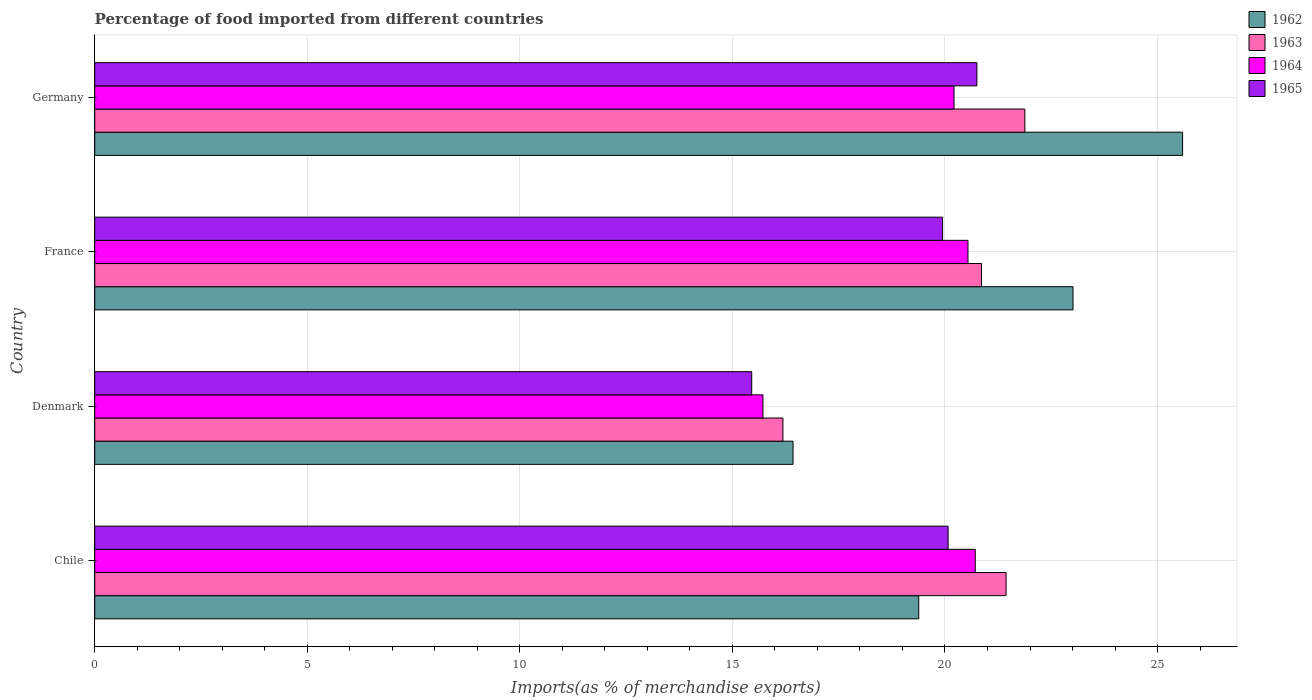Are the number of bars per tick equal to the number of legend labels?
Keep it short and to the point. Yes. Are the number of bars on each tick of the Y-axis equal?
Keep it short and to the point. Yes. How many bars are there on the 2nd tick from the bottom?
Your answer should be compact. 4. In how many cases, is the number of bars for a given country not equal to the number of legend labels?
Ensure brevity in your answer.  0. What is the percentage of imports to different countries in 1962 in France?
Ensure brevity in your answer.  23.01. Across all countries, what is the maximum percentage of imports to different countries in 1964?
Provide a succinct answer. 20.71. Across all countries, what is the minimum percentage of imports to different countries in 1965?
Your response must be concise. 15.45. In which country was the percentage of imports to different countries in 1965 maximum?
Provide a short and direct response. Germany. In which country was the percentage of imports to different countries in 1962 minimum?
Give a very brief answer. Denmark. What is the total percentage of imports to different countries in 1965 in the graph?
Keep it short and to the point. 76.22. What is the difference between the percentage of imports to different countries in 1963 in Chile and that in Denmark?
Offer a terse response. 5.25. What is the difference between the percentage of imports to different countries in 1965 in Chile and the percentage of imports to different countries in 1963 in Denmark?
Provide a succinct answer. 3.89. What is the average percentage of imports to different countries in 1962 per country?
Make the answer very short. 21.1. What is the difference between the percentage of imports to different countries in 1965 and percentage of imports to different countries in 1964 in Germany?
Your response must be concise. 0.54. In how many countries, is the percentage of imports to different countries in 1964 greater than 5 %?
Provide a succinct answer. 4. What is the ratio of the percentage of imports to different countries in 1962 in Chile to that in Denmark?
Provide a succinct answer. 1.18. Is the percentage of imports to different countries in 1964 in Chile less than that in Germany?
Keep it short and to the point. No. Is the difference between the percentage of imports to different countries in 1965 in Denmark and Germany greater than the difference between the percentage of imports to different countries in 1964 in Denmark and Germany?
Your answer should be very brief. No. What is the difference between the highest and the second highest percentage of imports to different countries in 1962?
Your answer should be very brief. 2.58. What is the difference between the highest and the lowest percentage of imports to different countries in 1962?
Keep it short and to the point. 9.16. In how many countries, is the percentage of imports to different countries in 1965 greater than the average percentage of imports to different countries in 1965 taken over all countries?
Your answer should be compact. 3. Is the sum of the percentage of imports to different countries in 1964 in Chile and France greater than the maximum percentage of imports to different countries in 1963 across all countries?
Keep it short and to the point. Yes. Is it the case that in every country, the sum of the percentage of imports to different countries in 1964 and percentage of imports to different countries in 1962 is greater than the sum of percentage of imports to different countries in 1965 and percentage of imports to different countries in 1963?
Offer a terse response. No. What does the 2nd bar from the top in Chile represents?
Provide a short and direct response. 1964. What does the 2nd bar from the bottom in France represents?
Provide a short and direct response. 1963. Is it the case that in every country, the sum of the percentage of imports to different countries in 1962 and percentage of imports to different countries in 1963 is greater than the percentage of imports to different countries in 1964?
Ensure brevity in your answer.  Yes. Are all the bars in the graph horizontal?
Provide a succinct answer. Yes. How many countries are there in the graph?
Offer a very short reply. 4. What is the difference between two consecutive major ticks on the X-axis?
Give a very brief answer. 5. Are the values on the major ticks of X-axis written in scientific E-notation?
Offer a terse response. No. Does the graph contain any zero values?
Keep it short and to the point. No. Where does the legend appear in the graph?
Offer a very short reply. Top right. How many legend labels are there?
Provide a succinct answer. 4. How are the legend labels stacked?
Provide a succinct answer. Vertical. What is the title of the graph?
Your answer should be very brief. Percentage of food imported from different countries. What is the label or title of the X-axis?
Your answer should be very brief. Imports(as % of merchandise exports). What is the Imports(as % of merchandise exports) in 1962 in Chile?
Offer a very short reply. 19.38. What is the Imports(as % of merchandise exports) of 1963 in Chile?
Ensure brevity in your answer.  21.44. What is the Imports(as % of merchandise exports) in 1964 in Chile?
Offer a terse response. 20.71. What is the Imports(as % of merchandise exports) in 1965 in Chile?
Provide a succinct answer. 20.07. What is the Imports(as % of merchandise exports) in 1962 in Denmark?
Provide a succinct answer. 16.43. What is the Imports(as % of merchandise exports) of 1963 in Denmark?
Ensure brevity in your answer.  16.19. What is the Imports(as % of merchandise exports) of 1964 in Denmark?
Give a very brief answer. 15.72. What is the Imports(as % of merchandise exports) in 1965 in Denmark?
Provide a short and direct response. 15.45. What is the Imports(as % of merchandise exports) of 1962 in France?
Provide a succinct answer. 23.01. What is the Imports(as % of merchandise exports) of 1963 in France?
Your answer should be compact. 20.86. What is the Imports(as % of merchandise exports) in 1964 in France?
Provide a succinct answer. 20.54. What is the Imports(as % of merchandise exports) of 1965 in France?
Give a very brief answer. 19.94. What is the Imports(as % of merchandise exports) in 1962 in Germany?
Ensure brevity in your answer.  25.59. What is the Imports(as % of merchandise exports) of 1963 in Germany?
Your answer should be very brief. 21.88. What is the Imports(as % of merchandise exports) of 1964 in Germany?
Provide a succinct answer. 20.21. What is the Imports(as % of merchandise exports) in 1965 in Germany?
Provide a short and direct response. 20.75. Across all countries, what is the maximum Imports(as % of merchandise exports) of 1962?
Keep it short and to the point. 25.59. Across all countries, what is the maximum Imports(as % of merchandise exports) of 1963?
Offer a very short reply. 21.88. Across all countries, what is the maximum Imports(as % of merchandise exports) of 1964?
Your response must be concise. 20.71. Across all countries, what is the maximum Imports(as % of merchandise exports) in 1965?
Make the answer very short. 20.75. Across all countries, what is the minimum Imports(as % of merchandise exports) of 1962?
Offer a very short reply. 16.43. Across all countries, what is the minimum Imports(as % of merchandise exports) of 1963?
Give a very brief answer. 16.19. Across all countries, what is the minimum Imports(as % of merchandise exports) of 1964?
Give a very brief answer. 15.72. Across all countries, what is the minimum Imports(as % of merchandise exports) in 1965?
Your answer should be compact. 15.45. What is the total Imports(as % of merchandise exports) of 1962 in the graph?
Provide a succinct answer. 84.41. What is the total Imports(as % of merchandise exports) in 1963 in the graph?
Your answer should be compact. 80.36. What is the total Imports(as % of merchandise exports) in 1964 in the graph?
Your response must be concise. 77.18. What is the total Imports(as % of merchandise exports) in 1965 in the graph?
Provide a short and direct response. 76.22. What is the difference between the Imports(as % of merchandise exports) of 1962 in Chile and that in Denmark?
Your response must be concise. 2.96. What is the difference between the Imports(as % of merchandise exports) of 1963 in Chile and that in Denmark?
Make the answer very short. 5.25. What is the difference between the Imports(as % of merchandise exports) in 1964 in Chile and that in Denmark?
Provide a succinct answer. 4.99. What is the difference between the Imports(as % of merchandise exports) of 1965 in Chile and that in Denmark?
Ensure brevity in your answer.  4.62. What is the difference between the Imports(as % of merchandise exports) in 1962 in Chile and that in France?
Your answer should be very brief. -3.63. What is the difference between the Imports(as % of merchandise exports) of 1963 in Chile and that in France?
Provide a succinct answer. 0.58. What is the difference between the Imports(as % of merchandise exports) in 1964 in Chile and that in France?
Make the answer very short. 0.17. What is the difference between the Imports(as % of merchandise exports) in 1965 in Chile and that in France?
Offer a terse response. 0.13. What is the difference between the Imports(as % of merchandise exports) of 1962 in Chile and that in Germany?
Provide a short and direct response. -6.21. What is the difference between the Imports(as % of merchandise exports) in 1963 in Chile and that in Germany?
Your answer should be compact. -0.44. What is the difference between the Imports(as % of merchandise exports) of 1964 in Chile and that in Germany?
Ensure brevity in your answer.  0.5. What is the difference between the Imports(as % of merchandise exports) in 1965 in Chile and that in Germany?
Your answer should be compact. -0.68. What is the difference between the Imports(as % of merchandise exports) of 1962 in Denmark and that in France?
Provide a succinct answer. -6.59. What is the difference between the Imports(as % of merchandise exports) in 1963 in Denmark and that in France?
Offer a terse response. -4.67. What is the difference between the Imports(as % of merchandise exports) of 1964 in Denmark and that in France?
Offer a very short reply. -4.82. What is the difference between the Imports(as % of merchandise exports) of 1965 in Denmark and that in France?
Give a very brief answer. -4.49. What is the difference between the Imports(as % of merchandise exports) of 1962 in Denmark and that in Germany?
Provide a succinct answer. -9.16. What is the difference between the Imports(as % of merchandise exports) in 1963 in Denmark and that in Germany?
Your answer should be very brief. -5.69. What is the difference between the Imports(as % of merchandise exports) in 1964 in Denmark and that in Germany?
Offer a terse response. -4.49. What is the difference between the Imports(as % of merchandise exports) in 1965 in Denmark and that in Germany?
Offer a terse response. -5.3. What is the difference between the Imports(as % of merchandise exports) in 1962 in France and that in Germany?
Your answer should be very brief. -2.58. What is the difference between the Imports(as % of merchandise exports) of 1963 in France and that in Germany?
Ensure brevity in your answer.  -1.02. What is the difference between the Imports(as % of merchandise exports) of 1964 in France and that in Germany?
Offer a terse response. 0.33. What is the difference between the Imports(as % of merchandise exports) in 1965 in France and that in Germany?
Your response must be concise. -0.81. What is the difference between the Imports(as % of merchandise exports) in 1962 in Chile and the Imports(as % of merchandise exports) in 1963 in Denmark?
Keep it short and to the point. 3.19. What is the difference between the Imports(as % of merchandise exports) of 1962 in Chile and the Imports(as % of merchandise exports) of 1964 in Denmark?
Provide a succinct answer. 3.66. What is the difference between the Imports(as % of merchandise exports) in 1962 in Chile and the Imports(as % of merchandise exports) in 1965 in Denmark?
Provide a short and direct response. 3.93. What is the difference between the Imports(as % of merchandise exports) in 1963 in Chile and the Imports(as % of merchandise exports) in 1964 in Denmark?
Provide a short and direct response. 5.72. What is the difference between the Imports(as % of merchandise exports) in 1963 in Chile and the Imports(as % of merchandise exports) in 1965 in Denmark?
Give a very brief answer. 5.98. What is the difference between the Imports(as % of merchandise exports) of 1964 in Chile and the Imports(as % of merchandise exports) of 1965 in Denmark?
Make the answer very short. 5.26. What is the difference between the Imports(as % of merchandise exports) of 1962 in Chile and the Imports(as % of merchandise exports) of 1963 in France?
Offer a terse response. -1.48. What is the difference between the Imports(as % of merchandise exports) of 1962 in Chile and the Imports(as % of merchandise exports) of 1964 in France?
Offer a terse response. -1.16. What is the difference between the Imports(as % of merchandise exports) of 1962 in Chile and the Imports(as % of merchandise exports) of 1965 in France?
Offer a very short reply. -0.56. What is the difference between the Imports(as % of merchandise exports) in 1963 in Chile and the Imports(as % of merchandise exports) in 1964 in France?
Your answer should be very brief. 0.9. What is the difference between the Imports(as % of merchandise exports) in 1963 in Chile and the Imports(as % of merchandise exports) in 1965 in France?
Your answer should be very brief. 1.49. What is the difference between the Imports(as % of merchandise exports) in 1964 in Chile and the Imports(as % of merchandise exports) in 1965 in France?
Offer a very short reply. 0.77. What is the difference between the Imports(as % of merchandise exports) in 1962 in Chile and the Imports(as % of merchandise exports) in 1963 in Germany?
Your response must be concise. -2.5. What is the difference between the Imports(as % of merchandise exports) in 1962 in Chile and the Imports(as % of merchandise exports) in 1964 in Germany?
Your answer should be compact. -0.83. What is the difference between the Imports(as % of merchandise exports) in 1962 in Chile and the Imports(as % of merchandise exports) in 1965 in Germany?
Provide a succinct answer. -1.37. What is the difference between the Imports(as % of merchandise exports) in 1963 in Chile and the Imports(as % of merchandise exports) in 1964 in Germany?
Ensure brevity in your answer.  1.22. What is the difference between the Imports(as % of merchandise exports) in 1963 in Chile and the Imports(as % of merchandise exports) in 1965 in Germany?
Your answer should be very brief. 0.69. What is the difference between the Imports(as % of merchandise exports) in 1964 in Chile and the Imports(as % of merchandise exports) in 1965 in Germany?
Ensure brevity in your answer.  -0.04. What is the difference between the Imports(as % of merchandise exports) of 1962 in Denmark and the Imports(as % of merchandise exports) of 1963 in France?
Ensure brevity in your answer.  -4.43. What is the difference between the Imports(as % of merchandise exports) of 1962 in Denmark and the Imports(as % of merchandise exports) of 1964 in France?
Provide a short and direct response. -4.11. What is the difference between the Imports(as % of merchandise exports) in 1962 in Denmark and the Imports(as % of merchandise exports) in 1965 in France?
Offer a very short reply. -3.52. What is the difference between the Imports(as % of merchandise exports) of 1963 in Denmark and the Imports(as % of merchandise exports) of 1964 in France?
Give a very brief answer. -4.35. What is the difference between the Imports(as % of merchandise exports) in 1963 in Denmark and the Imports(as % of merchandise exports) in 1965 in France?
Your answer should be very brief. -3.76. What is the difference between the Imports(as % of merchandise exports) of 1964 in Denmark and the Imports(as % of merchandise exports) of 1965 in France?
Provide a succinct answer. -4.23. What is the difference between the Imports(as % of merchandise exports) in 1962 in Denmark and the Imports(as % of merchandise exports) in 1963 in Germany?
Ensure brevity in your answer.  -5.45. What is the difference between the Imports(as % of merchandise exports) of 1962 in Denmark and the Imports(as % of merchandise exports) of 1964 in Germany?
Offer a terse response. -3.79. What is the difference between the Imports(as % of merchandise exports) in 1962 in Denmark and the Imports(as % of merchandise exports) in 1965 in Germany?
Your response must be concise. -4.32. What is the difference between the Imports(as % of merchandise exports) in 1963 in Denmark and the Imports(as % of merchandise exports) in 1964 in Germany?
Provide a succinct answer. -4.02. What is the difference between the Imports(as % of merchandise exports) in 1963 in Denmark and the Imports(as % of merchandise exports) in 1965 in Germany?
Offer a terse response. -4.56. What is the difference between the Imports(as % of merchandise exports) of 1964 in Denmark and the Imports(as % of merchandise exports) of 1965 in Germany?
Keep it short and to the point. -5.03. What is the difference between the Imports(as % of merchandise exports) in 1962 in France and the Imports(as % of merchandise exports) in 1963 in Germany?
Ensure brevity in your answer.  1.13. What is the difference between the Imports(as % of merchandise exports) of 1962 in France and the Imports(as % of merchandise exports) of 1964 in Germany?
Keep it short and to the point. 2.8. What is the difference between the Imports(as % of merchandise exports) of 1962 in France and the Imports(as % of merchandise exports) of 1965 in Germany?
Your answer should be compact. 2.26. What is the difference between the Imports(as % of merchandise exports) of 1963 in France and the Imports(as % of merchandise exports) of 1964 in Germany?
Your answer should be compact. 0.65. What is the difference between the Imports(as % of merchandise exports) of 1963 in France and the Imports(as % of merchandise exports) of 1965 in Germany?
Ensure brevity in your answer.  0.11. What is the difference between the Imports(as % of merchandise exports) of 1964 in France and the Imports(as % of merchandise exports) of 1965 in Germany?
Offer a terse response. -0.21. What is the average Imports(as % of merchandise exports) in 1962 per country?
Keep it short and to the point. 21.1. What is the average Imports(as % of merchandise exports) of 1963 per country?
Ensure brevity in your answer.  20.09. What is the average Imports(as % of merchandise exports) in 1964 per country?
Offer a terse response. 19.3. What is the average Imports(as % of merchandise exports) of 1965 per country?
Ensure brevity in your answer.  19.06. What is the difference between the Imports(as % of merchandise exports) of 1962 and Imports(as % of merchandise exports) of 1963 in Chile?
Provide a short and direct response. -2.05. What is the difference between the Imports(as % of merchandise exports) of 1962 and Imports(as % of merchandise exports) of 1964 in Chile?
Keep it short and to the point. -1.33. What is the difference between the Imports(as % of merchandise exports) of 1962 and Imports(as % of merchandise exports) of 1965 in Chile?
Provide a succinct answer. -0.69. What is the difference between the Imports(as % of merchandise exports) of 1963 and Imports(as % of merchandise exports) of 1964 in Chile?
Give a very brief answer. 0.72. What is the difference between the Imports(as % of merchandise exports) in 1963 and Imports(as % of merchandise exports) in 1965 in Chile?
Provide a short and direct response. 1.36. What is the difference between the Imports(as % of merchandise exports) in 1964 and Imports(as % of merchandise exports) in 1965 in Chile?
Make the answer very short. 0.64. What is the difference between the Imports(as % of merchandise exports) in 1962 and Imports(as % of merchandise exports) in 1963 in Denmark?
Offer a terse response. 0.24. What is the difference between the Imports(as % of merchandise exports) in 1962 and Imports(as % of merchandise exports) in 1964 in Denmark?
Ensure brevity in your answer.  0.71. What is the difference between the Imports(as % of merchandise exports) of 1962 and Imports(as % of merchandise exports) of 1965 in Denmark?
Give a very brief answer. 0.97. What is the difference between the Imports(as % of merchandise exports) in 1963 and Imports(as % of merchandise exports) in 1964 in Denmark?
Your answer should be compact. 0.47. What is the difference between the Imports(as % of merchandise exports) in 1963 and Imports(as % of merchandise exports) in 1965 in Denmark?
Ensure brevity in your answer.  0.73. What is the difference between the Imports(as % of merchandise exports) of 1964 and Imports(as % of merchandise exports) of 1965 in Denmark?
Keep it short and to the point. 0.26. What is the difference between the Imports(as % of merchandise exports) in 1962 and Imports(as % of merchandise exports) in 1963 in France?
Make the answer very short. 2.15. What is the difference between the Imports(as % of merchandise exports) of 1962 and Imports(as % of merchandise exports) of 1964 in France?
Offer a terse response. 2.47. What is the difference between the Imports(as % of merchandise exports) in 1962 and Imports(as % of merchandise exports) in 1965 in France?
Give a very brief answer. 3.07. What is the difference between the Imports(as % of merchandise exports) in 1963 and Imports(as % of merchandise exports) in 1964 in France?
Your answer should be very brief. 0.32. What is the difference between the Imports(as % of merchandise exports) of 1963 and Imports(as % of merchandise exports) of 1965 in France?
Offer a terse response. 0.92. What is the difference between the Imports(as % of merchandise exports) of 1964 and Imports(as % of merchandise exports) of 1965 in France?
Offer a terse response. 0.6. What is the difference between the Imports(as % of merchandise exports) in 1962 and Imports(as % of merchandise exports) in 1963 in Germany?
Give a very brief answer. 3.71. What is the difference between the Imports(as % of merchandise exports) in 1962 and Imports(as % of merchandise exports) in 1964 in Germany?
Your answer should be very brief. 5.38. What is the difference between the Imports(as % of merchandise exports) in 1962 and Imports(as % of merchandise exports) in 1965 in Germany?
Keep it short and to the point. 4.84. What is the difference between the Imports(as % of merchandise exports) of 1963 and Imports(as % of merchandise exports) of 1964 in Germany?
Make the answer very short. 1.67. What is the difference between the Imports(as % of merchandise exports) in 1963 and Imports(as % of merchandise exports) in 1965 in Germany?
Provide a succinct answer. 1.13. What is the difference between the Imports(as % of merchandise exports) of 1964 and Imports(as % of merchandise exports) of 1965 in Germany?
Offer a very short reply. -0.54. What is the ratio of the Imports(as % of merchandise exports) of 1962 in Chile to that in Denmark?
Ensure brevity in your answer.  1.18. What is the ratio of the Imports(as % of merchandise exports) of 1963 in Chile to that in Denmark?
Your answer should be compact. 1.32. What is the ratio of the Imports(as % of merchandise exports) in 1964 in Chile to that in Denmark?
Provide a short and direct response. 1.32. What is the ratio of the Imports(as % of merchandise exports) in 1965 in Chile to that in Denmark?
Offer a terse response. 1.3. What is the ratio of the Imports(as % of merchandise exports) of 1962 in Chile to that in France?
Your answer should be compact. 0.84. What is the ratio of the Imports(as % of merchandise exports) in 1963 in Chile to that in France?
Offer a terse response. 1.03. What is the ratio of the Imports(as % of merchandise exports) in 1964 in Chile to that in France?
Ensure brevity in your answer.  1.01. What is the ratio of the Imports(as % of merchandise exports) of 1965 in Chile to that in France?
Your answer should be compact. 1.01. What is the ratio of the Imports(as % of merchandise exports) in 1962 in Chile to that in Germany?
Your answer should be compact. 0.76. What is the ratio of the Imports(as % of merchandise exports) of 1963 in Chile to that in Germany?
Ensure brevity in your answer.  0.98. What is the ratio of the Imports(as % of merchandise exports) of 1964 in Chile to that in Germany?
Ensure brevity in your answer.  1.02. What is the ratio of the Imports(as % of merchandise exports) in 1965 in Chile to that in Germany?
Provide a short and direct response. 0.97. What is the ratio of the Imports(as % of merchandise exports) in 1962 in Denmark to that in France?
Your response must be concise. 0.71. What is the ratio of the Imports(as % of merchandise exports) in 1963 in Denmark to that in France?
Ensure brevity in your answer.  0.78. What is the ratio of the Imports(as % of merchandise exports) of 1964 in Denmark to that in France?
Keep it short and to the point. 0.77. What is the ratio of the Imports(as % of merchandise exports) of 1965 in Denmark to that in France?
Provide a short and direct response. 0.77. What is the ratio of the Imports(as % of merchandise exports) in 1962 in Denmark to that in Germany?
Provide a short and direct response. 0.64. What is the ratio of the Imports(as % of merchandise exports) in 1963 in Denmark to that in Germany?
Make the answer very short. 0.74. What is the ratio of the Imports(as % of merchandise exports) of 1964 in Denmark to that in Germany?
Offer a terse response. 0.78. What is the ratio of the Imports(as % of merchandise exports) in 1965 in Denmark to that in Germany?
Give a very brief answer. 0.74. What is the ratio of the Imports(as % of merchandise exports) in 1962 in France to that in Germany?
Provide a succinct answer. 0.9. What is the ratio of the Imports(as % of merchandise exports) in 1963 in France to that in Germany?
Give a very brief answer. 0.95. What is the ratio of the Imports(as % of merchandise exports) of 1964 in France to that in Germany?
Provide a short and direct response. 1.02. What is the ratio of the Imports(as % of merchandise exports) of 1965 in France to that in Germany?
Offer a very short reply. 0.96. What is the difference between the highest and the second highest Imports(as % of merchandise exports) in 1962?
Keep it short and to the point. 2.58. What is the difference between the highest and the second highest Imports(as % of merchandise exports) of 1963?
Your answer should be compact. 0.44. What is the difference between the highest and the second highest Imports(as % of merchandise exports) in 1964?
Offer a very short reply. 0.17. What is the difference between the highest and the second highest Imports(as % of merchandise exports) in 1965?
Your answer should be very brief. 0.68. What is the difference between the highest and the lowest Imports(as % of merchandise exports) of 1962?
Make the answer very short. 9.16. What is the difference between the highest and the lowest Imports(as % of merchandise exports) in 1963?
Provide a short and direct response. 5.69. What is the difference between the highest and the lowest Imports(as % of merchandise exports) in 1964?
Provide a succinct answer. 4.99. What is the difference between the highest and the lowest Imports(as % of merchandise exports) in 1965?
Your answer should be very brief. 5.3. 